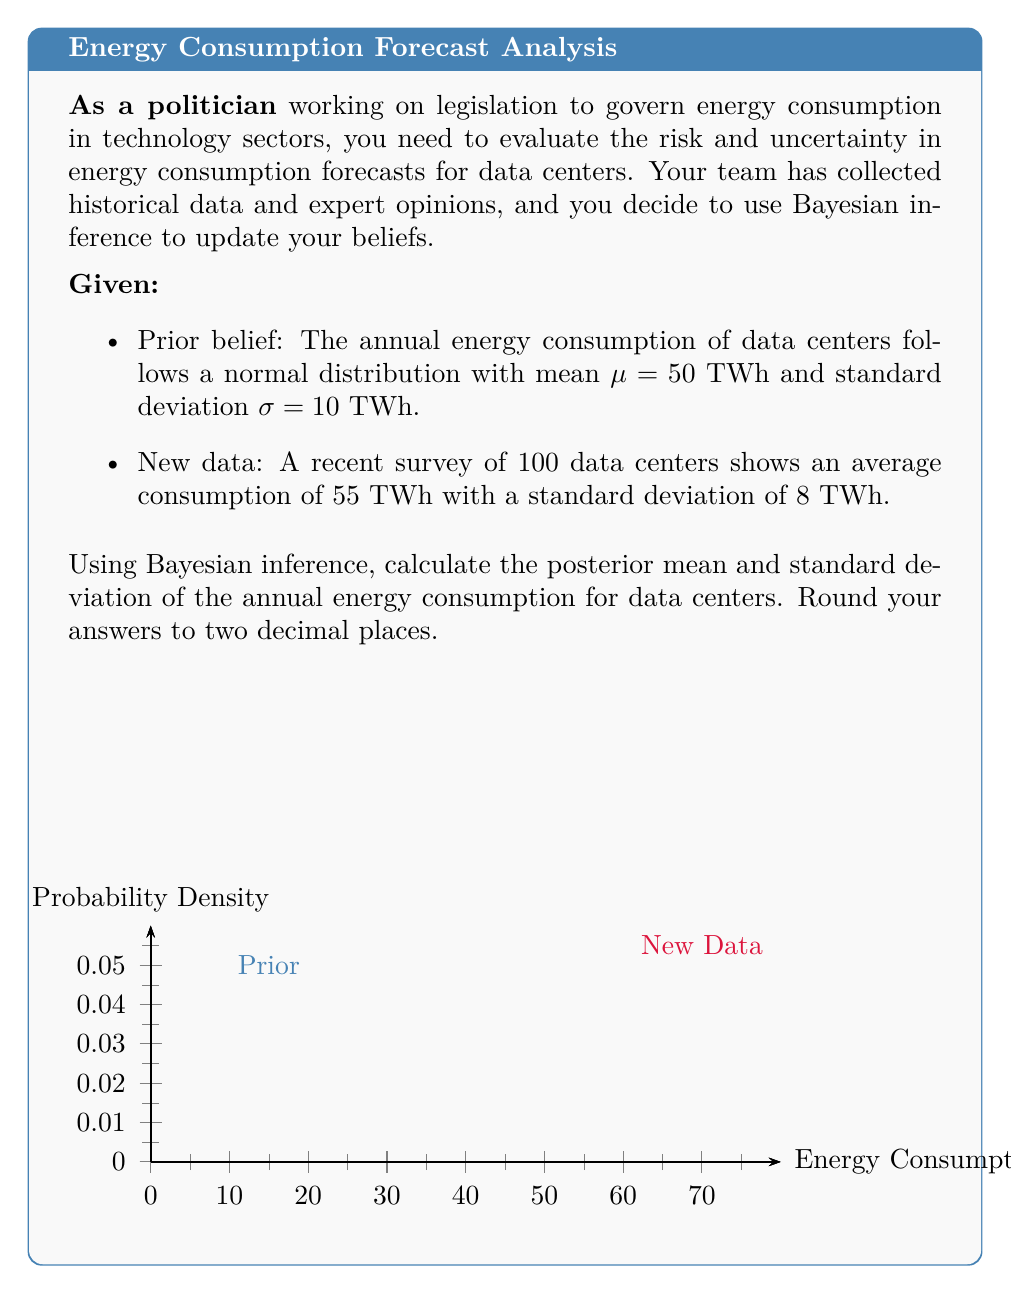What is the answer to this math problem? To solve this problem using Bayesian inference, we'll follow these steps:

1) In Bayesian inference, we combine prior beliefs with new data to obtain a posterior distribution. For normal distributions, the posterior is also normal.

2) Let's define our variables:
   μ₀ = 50 (prior mean)
   σ₀ = 10 (prior standard deviation)
   x̄ = 55 (sample mean from new data)
   σ = 8 (sample standard deviation)
   n = 100 (sample size)

3) The formulas for the posterior mean (μ₁) and posterior precision (1/σ₁²) are:

   $$\mu_1 = \frac{\frac{\mu_0}{\sigma_0^2} + \frac{nx̄}{\sigma^2}}{\frac{1}{\sigma_0^2} + \frac{n}{\sigma^2}}$$

   $$\frac{1}{\sigma_1^2} = \frac{1}{\sigma_0^2} + \frac{n}{\sigma^2}$$

4) Let's calculate the posterior precision first:

   $$\frac{1}{\sigma_1^2} = \frac{1}{10^2} + \frac{100}{8^2} = 0.01 + 1.5625 = 1.5725$$

5) Now we can calculate σ₁:

   $$\sigma_1 = \sqrt{\frac{1}{1.5725}} = 0.7972$$

6) Next, let's calculate the posterior mean:

   $$\mu_1 = \frac{\frac{50}{10^2} + \frac{100 * 55}{8^2}}{\frac{1}{10^2} + \frac{100}{8^2}} = \frac{0.5 + 85.9375}{1.5725} = 54.9778$$

7) Rounding to two decimal places:
   Posterior mean (μ₁) = 54.98 TWh
   Posterior standard deviation (σ₁) = 0.80 TWh

This result suggests that after incorporating the new data, we have updated our belief about the annual energy consumption of data centers. We now believe it's likely higher than our prior estimate and we're more certain about this estimate (as indicated by the smaller standard deviation).
Answer: Posterior mean: 54.98 TWh, Posterior standard deviation: 0.80 TWh 